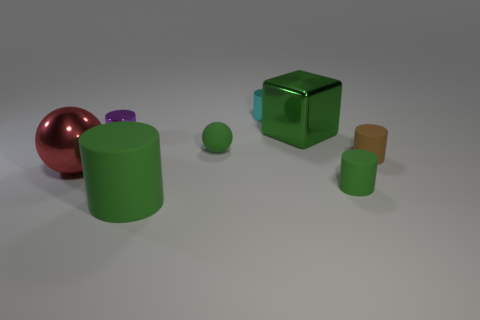Subtract all small brown cylinders. How many cylinders are left? 4 Add 1 small cyan objects. How many objects exist? 9 Subtract all green cylinders. How many cylinders are left? 3 Subtract all gray blocks. How many green cylinders are left? 2 Subtract all balls. How many objects are left? 6 Subtract 1 blocks. How many blocks are left? 0 Subtract all blue cubes. Subtract all purple cylinders. How many cubes are left? 1 Subtract all tiny green things. Subtract all green matte cylinders. How many objects are left? 4 Add 3 cubes. How many cubes are left? 4 Add 6 cyan cylinders. How many cyan cylinders exist? 7 